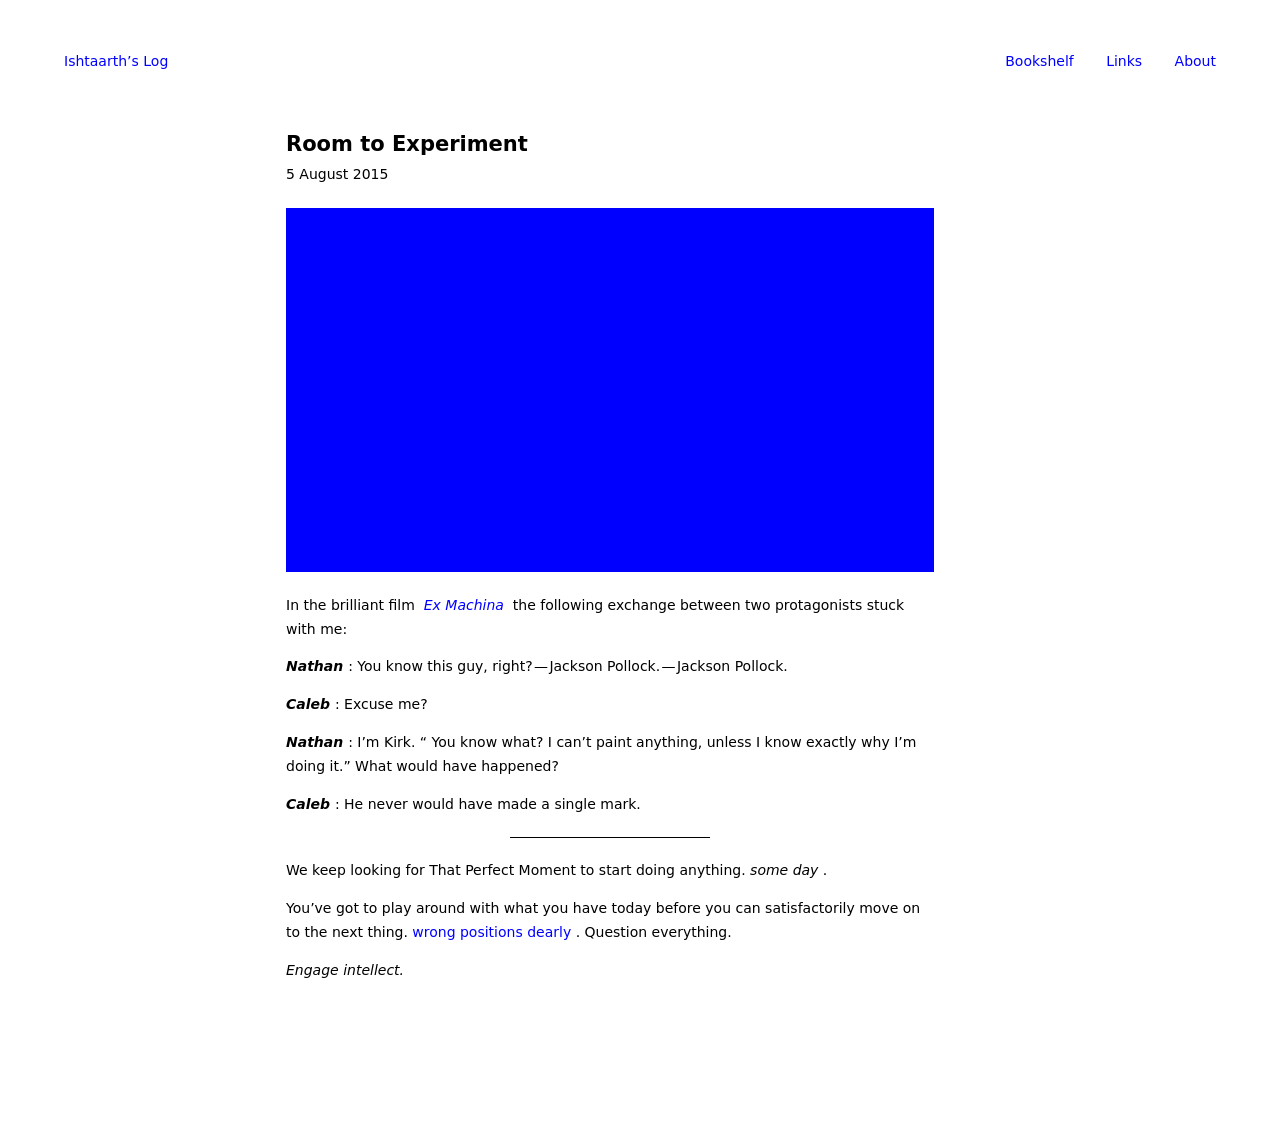What does the blue image on this web page represent? The blue image on the webpage appears to be a placeholder or an artistic representation to accompany the content, possibly reflecting the theme of 'Room to Experiment'. It emphasizes creativity and openness, aligning with the discussion themes from the movie Ex Machina, as mentioned in the text.  How could this visual element be made more engaging or informative? To make the blue image more engaging or informative, consider adding interactive elements such as hover effects that display quotes or insights from the movie 'Ex Machina'. Alternatively, it could transform into a visual representation of Jackson Pollock's artwork style, directly linking to the content discussed in the article. 